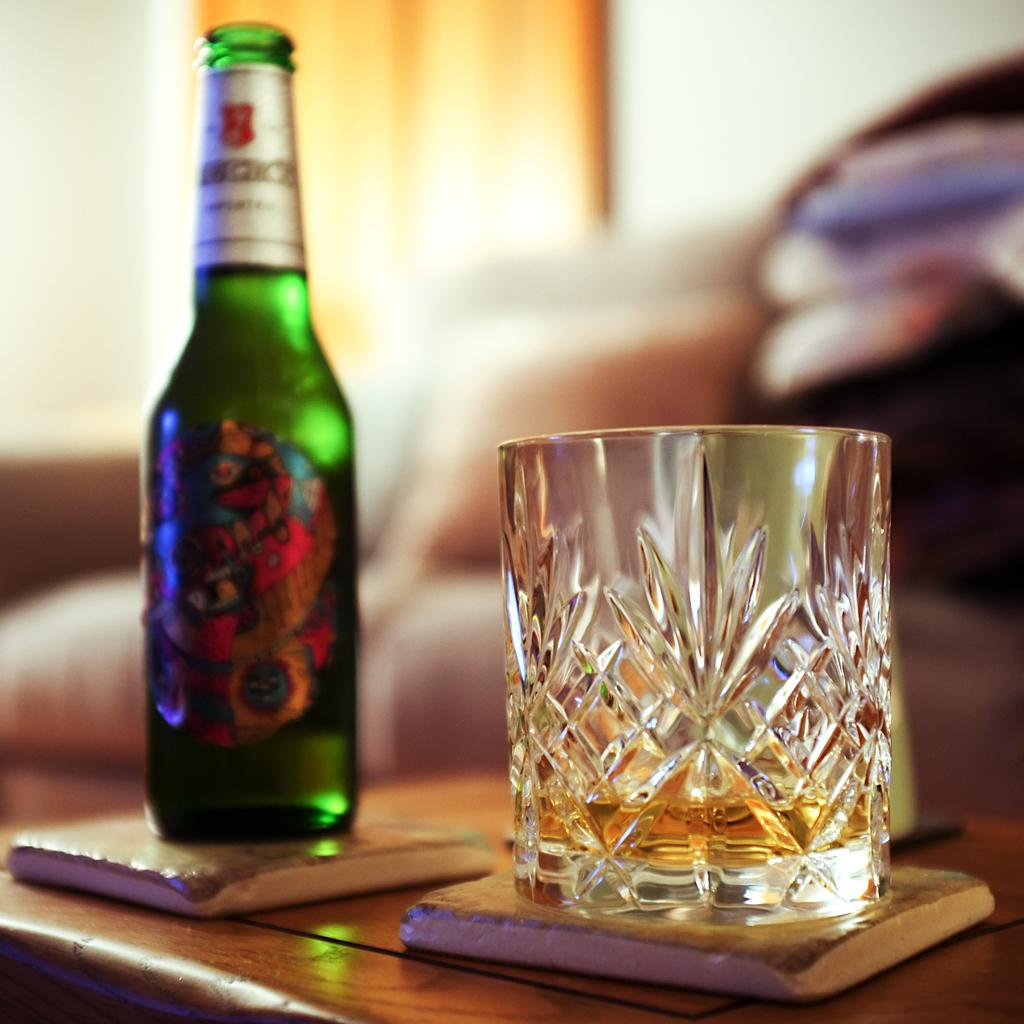<image>
Share a concise interpretation of the image provided. A bottle of beer that has illegible text is next to a glass. 